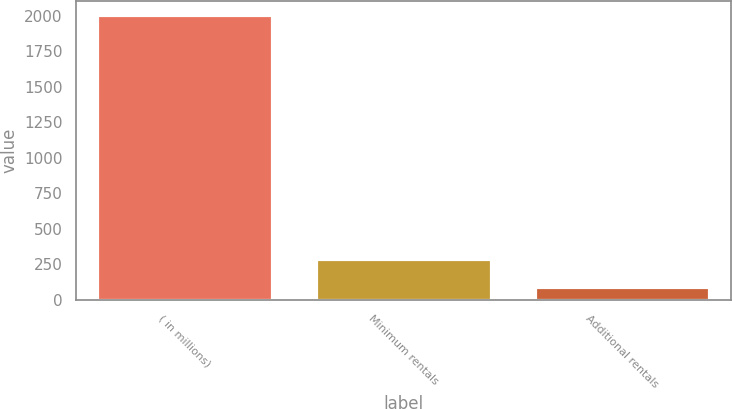Convert chart. <chart><loc_0><loc_0><loc_500><loc_500><bar_chart><fcel>( in millions)<fcel>Minimum rentals<fcel>Additional rentals<nl><fcel>2004<fcel>284.1<fcel>93<nl></chart> 